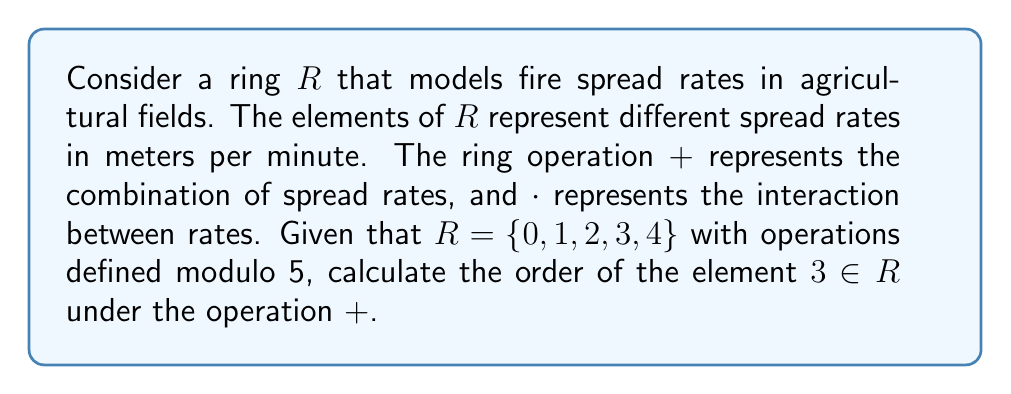Show me your answer to this math problem. To find the order of an element in a ring under addition, we need to determine the smallest positive integer $n$ such that $n$ times the element equals the additive identity (0 in this case).

Let's calculate the multiples of 3 in the ring $R$:

1. $3 + 0 = 3$
2. $3 + 3 = 1$ (since $6 \equiv 1 \pmod{5}$)
3. $3 + 3 + 3 = 1 + 3 = 4$
4. $3 + 3 + 3 + 3 = 4 + 3 = 2$
5. $3 + 3 + 3 + 3 + 3 = 2 + 3 = 0$

We see that it takes 5 additions of 3 to reach the additive identity 0. Therefore, the order of 3 in the ring $R$ under addition is 5.

This result is consistent with the fact that the additive group of the ring $R$ is isomorphic to $\mathbb{Z}_5$, which has order 5 for all non-zero elements.

In the context of fire spread rates, this means that combining the spread rate represented by 3 with itself 5 times results in a net spread rate of 0, which could be interpreted as the fire returning to its starting point or neutralizing its own spread in this simplified model.
Answer: The order of the element $3$ in the ring $R$ under addition is $5$. 